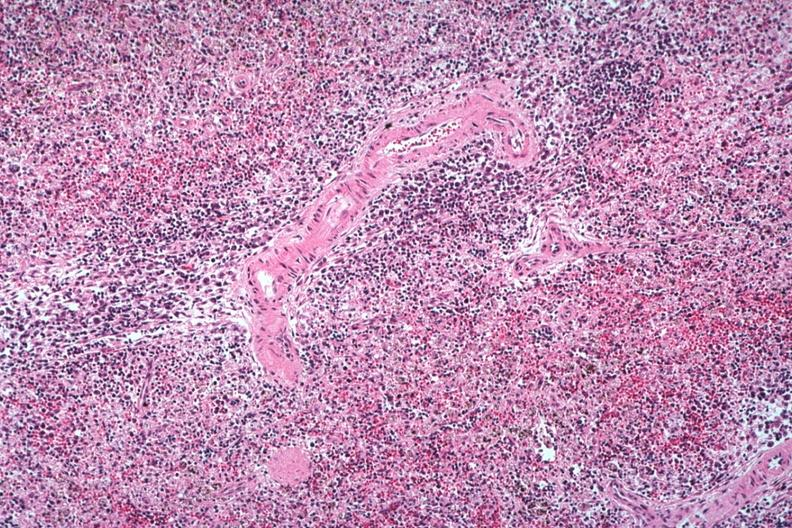what is well seen atypical cells surrounding splenic arteriole man died?
Answer the question using a single word or phrase. Of viral pneumonia likely to have been influenzae 